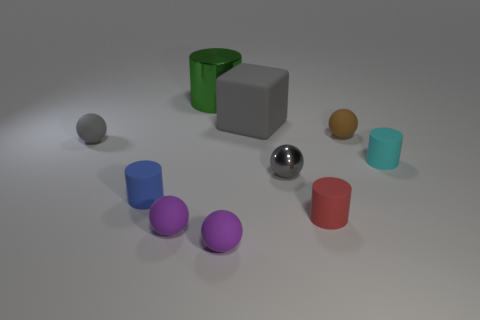Do the metallic sphere and the matte cube have the same color?
Your response must be concise. Yes. Is the size of the green shiny thing that is behind the blue thing the same as the cyan object?
Ensure brevity in your answer.  No. Are there fewer gray matte blocks that are on the left side of the big gray cube than small brown objects?
Offer a very short reply. Yes. What is the size of the cylinder that is behind the matte cylinder right of the small red cylinder?
Keep it short and to the point. Large. Is there anything else that is the same shape as the large gray object?
Offer a terse response. No. Is the number of tiny blue rubber cylinders less than the number of purple cubes?
Give a very brief answer. No. What is the material of the sphere that is both on the right side of the green shiny cylinder and in front of the small red thing?
Make the answer very short. Rubber. There is a gray shiny ball that is in front of the big shiny thing; are there any big cylinders right of it?
Offer a very short reply. No. What number of things are either small blue matte objects or blocks?
Your response must be concise. 2. There is a object that is to the right of the red matte thing and left of the small cyan matte object; what is its shape?
Provide a succinct answer. Sphere. 